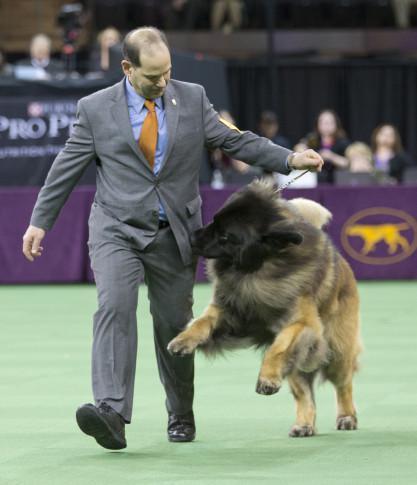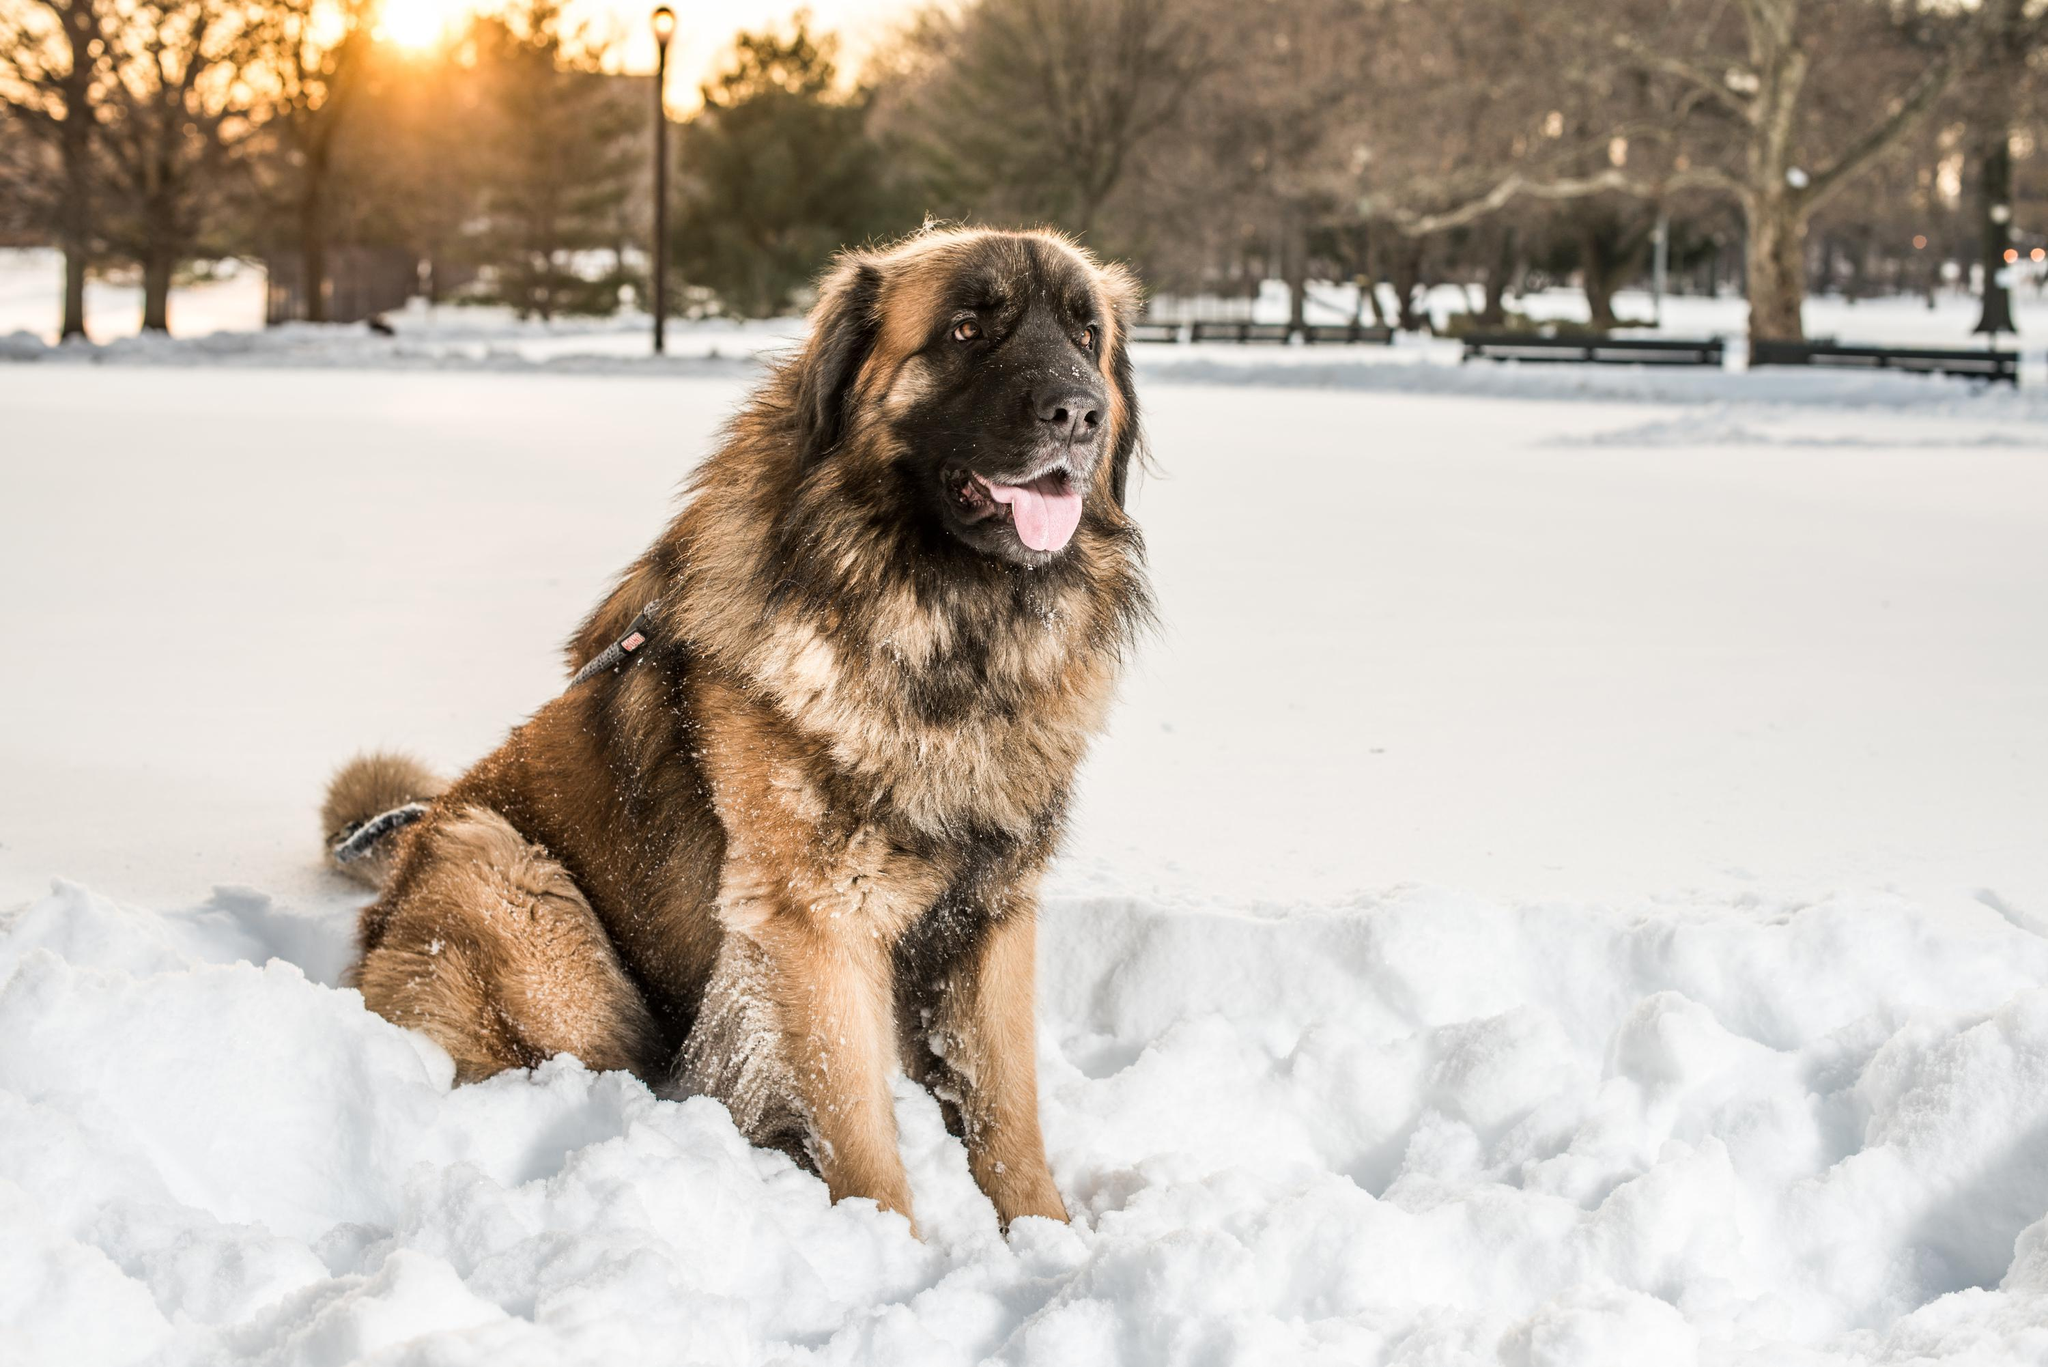The first image is the image on the left, the second image is the image on the right. Evaluate the accuracy of this statement regarding the images: "There are more than two dogs visible.". Is it true? Answer yes or no. No. The first image is the image on the left, the second image is the image on the right. Considering the images on both sides, is "Exactly one image, the one on the left, shows a dog tugging on the pocket of its handler at a dog show, and the handler is wearing a brownish-yellow necktie." valid? Answer yes or no. Yes. 